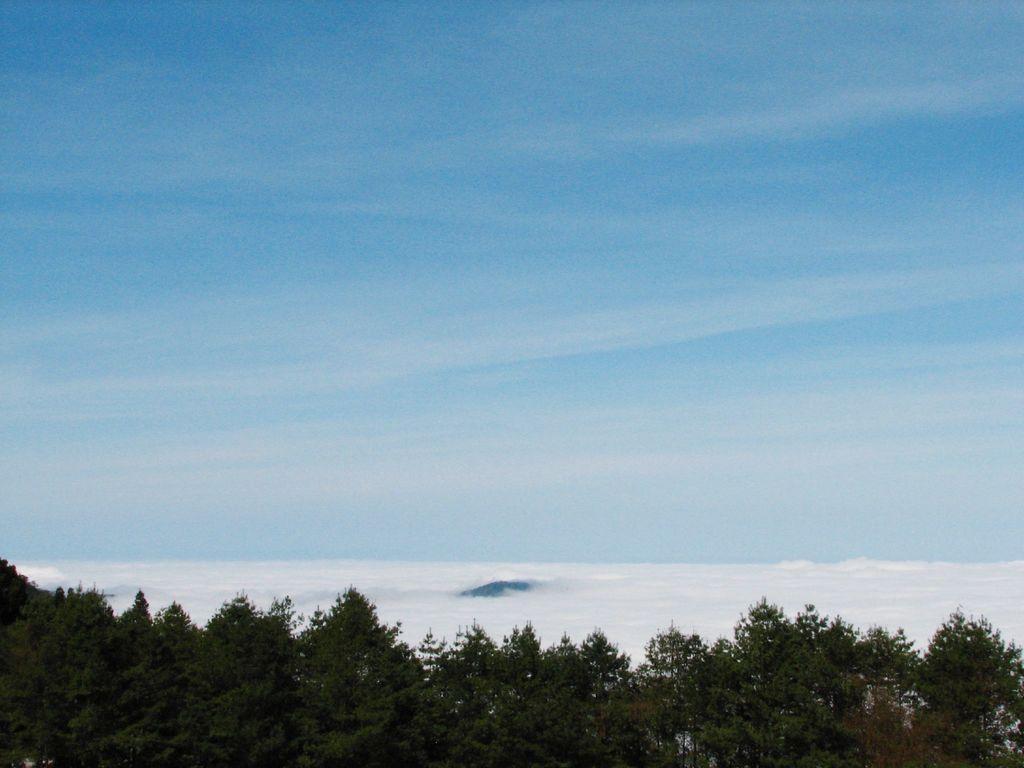Can you describe this image briefly? In this picture I can see number of trees in front and in the background I can see the sky. 